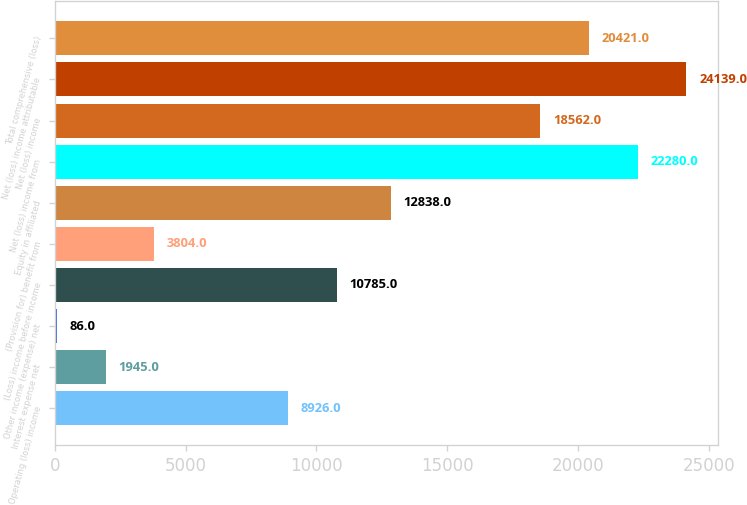<chart> <loc_0><loc_0><loc_500><loc_500><bar_chart><fcel>Operating (loss) income<fcel>Interest expense net<fcel>Other income (expense) net<fcel>(Loss) income before income<fcel>(Provision for) benefit from<fcel>Equity in affiliated<fcel>Net (loss) income from<fcel>Net (loss) income<fcel>Net (loss) income attributable<fcel>Total comprehensive (loss)<nl><fcel>8926<fcel>1945<fcel>86<fcel>10785<fcel>3804<fcel>12838<fcel>22280<fcel>18562<fcel>24139<fcel>20421<nl></chart> 